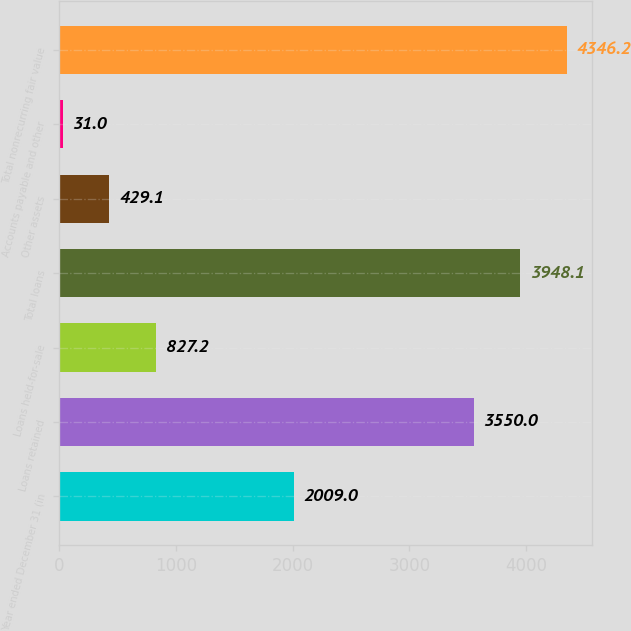Convert chart to OTSL. <chart><loc_0><loc_0><loc_500><loc_500><bar_chart><fcel>Year ended December 31 (in<fcel>Loans retained<fcel>Loans held-for-sale<fcel>Total loans<fcel>Other assets<fcel>Accounts payable and other<fcel>Total nonrecurring fair value<nl><fcel>2009<fcel>3550<fcel>827.2<fcel>3948.1<fcel>429.1<fcel>31<fcel>4346.2<nl></chart> 